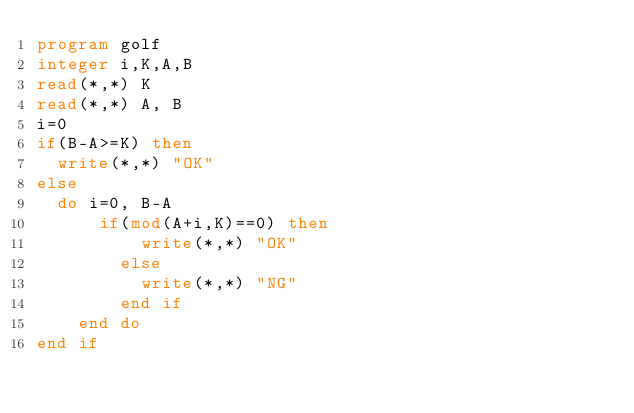Convert code to text. <code><loc_0><loc_0><loc_500><loc_500><_FORTRAN_>program golf
integer i,K,A,B
read(*,*) K
read(*,*) A, B
i=0
if(B-A>=K) then
	write(*,*) "OK"
else
	do i=0, B-A
	    if(mod(A+i,K)==0) then
        	write(*,*) "OK"
        else
        	write(*,*) "NG"
        end if
    end do
end if
</code> 